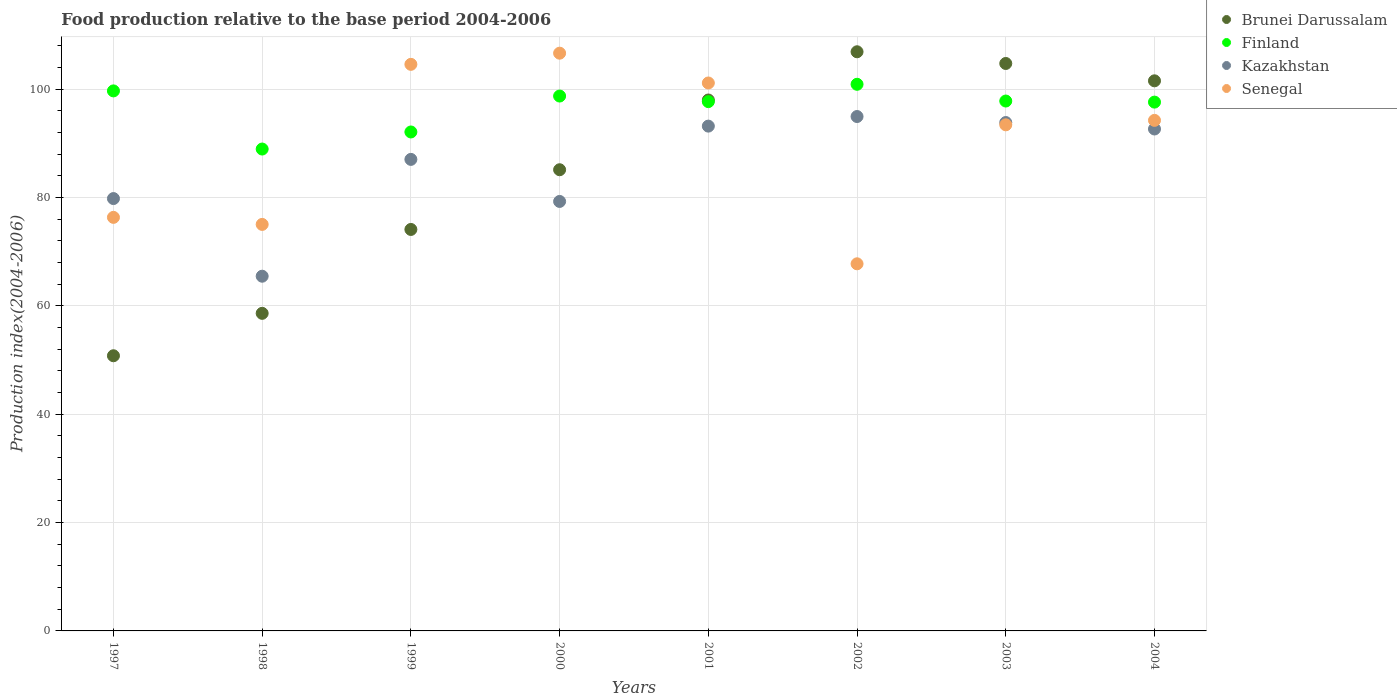How many different coloured dotlines are there?
Provide a succinct answer. 4. What is the food production index in Finland in 2002?
Ensure brevity in your answer.  100.88. Across all years, what is the maximum food production index in Finland?
Keep it short and to the point. 100.88. Across all years, what is the minimum food production index in Brunei Darussalam?
Offer a terse response. 50.78. What is the total food production index in Brunei Darussalam in the graph?
Make the answer very short. 679.69. What is the difference between the food production index in Senegal in 1998 and that in 2004?
Your answer should be very brief. -19.2. What is the difference between the food production index in Kazakhstan in 1997 and the food production index in Senegal in 2001?
Keep it short and to the point. -21.33. What is the average food production index in Finland per year?
Provide a succinct answer. 96.66. In the year 1998, what is the difference between the food production index in Senegal and food production index in Brunei Darussalam?
Ensure brevity in your answer.  16.41. What is the ratio of the food production index in Senegal in 1997 to that in 2003?
Offer a terse response. 0.82. What is the difference between the highest and the second highest food production index in Finland?
Your answer should be very brief. 1.22. What is the difference between the highest and the lowest food production index in Senegal?
Offer a very short reply. 38.87. Is the sum of the food production index in Finland in 1997 and 2002 greater than the maximum food production index in Brunei Darussalam across all years?
Ensure brevity in your answer.  Yes. Is it the case that in every year, the sum of the food production index in Finland and food production index in Senegal  is greater than the food production index in Kazakhstan?
Ensure brevity in your answer.  Yes. Does the food production index in Finland monotonically increase over the years?
Your response must be concise. No. Is the food production index in Kazakhstan strictly less than the food production index in Brunei Darussalam over the years?
Ensure brevity in your answer.  No. How many years are there in the graph?
Provide a short and direct response. 8. What is the difference between two consecutive major ticks on the Y-axis?
Ensure brevity in your answer.  20. Does the graph contain any zero values?
Your answer should be very brief. No. Where does the legend appear in the graph?
Your answer should be compact. Top right. How are the legend labels stacked?
Your answer should be compact. Vertical. What is the title of the graph?
Make the answer very short. Food production relative to the base period 2004-2006. Does "Albania" appear as one of the legend labels in the graph?
Give a very brief answer. No. What is the label or title of the X-axis?
Provide a short and direct response. Years. What is the label or title of the Y-axis?
Give a very brief answer. Production index(2004-2006). What is the Production index(2004-2006) of Brunei Darussalam in 1997?
Provide a short and direct response. 50.78. What is the Production index(2004-2006) in Finland in 1997?
Your answer should be very brief. 99.66. What is the Production index(2004-2006) of Kazakhstan in 1997?
Provide a succinct answer. 79.79. What is the Production index(2004-2006) in Senegal in 1997?
Your response must be concise. 76.32. What is the Production index(2004-2006) of Brunei Darussalam in 1998?
Your response must be concise. 58.61. What is the Production index(2004-2006) of Finland in 1998?
Ensure brevity in your answer.  88.93. What is the Production index(2004-2006) in Kazakhstan in 1998?
Provide a succinct answer. 65.46. What is the Production index(2004-2006) of Senegal in 1998?
Give a very brief answer. 75.02. What is the Production index(2004-2006) in Brunei Darussalam in 1999?
Make the answer very short. 74.09. What is the Production index(2004-2006) of Finland in 1999?
Make the answer very short. 92.08. What is the Production index(2004-2006) in Kazakhstan in 1999?
Offer a very short reply. 87.02. What is the Production index(2004-2006) in Senegal in 1999?
Offer a terse response. 104.56. What is the Production index(2004-2006) in Brunei Darussalam in 2000?
Provide a short and direct response. 85.11. What is the Production index(2004-2006) of Finland in 2000?
Make the answer very short. 98.71. What is the Production index(2004-2006) of Kazakhstan in 2000?
Give a very brief answer. 79.26. What is the Production index(2004-2006) in Senegal in 2000?
Offer a terse response. 106.62. What is the Production index(2004-2006) of Brunei Darussalam in 2001?
Your response must be concise. 97.98. What is the Production index(2004-2006) in Finland in 2001?
Keep it short and to the point. 97.68. What is the Production index(2004-2006) of Kazakhstan in 2001?
Your answer should be very brief. 93.16. What is the Production index(2004-2006) of Senegal in 2001?
Give a very brief answer. 101.12. What is the Production index(2004-2006) in Brunei Darussalam in 2002?
Your answer should be compact. 106.88. What is the Production index(2004-2006) in Finland in 2002?
Make the answer very short. 100.88. What is the Production index(2004-2006) in Kazakhstan in 2002?
Offer a very short reply. 94.93. What is the Production index(2004-2006) of Senegal in 2002?
Give a very brief answer. 67.75. What is the Production index(2004-2006) in Brunei Darussalam in 2003?
Your answer should be very brief. 104.72. What is the Production index(2004-2006) of Finland in 2003?
Offer a terse response. 97.79. What is the Production index(2004-2006) in Kazakhstan in 2003?
Ensure brevity in your answer.  93.82. What is the Production index(2004-2006) in Senegal in 2003?
Ensure brevity in your answer.  93.4. What is the Production index(2004-2006) in Brunei Darussalam in 2004?
Provide a short and direct response. 101.52. What is the Production index(2004-2006) in Finland in 2004?
Ensure brevity in your answer.  97.59. What is the Production index(2004-2006) in Kazakhstan in 2004?
Your answer should be very brief. 92.63. What is the Production index(2004-2006) of Senegal in 2004?
Keep it short and to the point. 94.22. Across all years, what is the maximum Production index(2004-2006) in Brunei Darussalam?
Give a very brief answer. 106.88. Across all years, what is the maximum Production index(2004-2006) in Finland?
Provide a succinct answer. 100.88. Across all years, what is the maximum Production index(2004-2006) of Kazakhstan?
Ensure brevity in your answer.  94.93. Across all years, what is the maximum Production index(2004-2006) of Senegal?
Keep it short and to the point. 106.62. Across all years, what is the minimum Production index(2004-2006) of Brunei Darussalam?
Offer a very short reply. 50.78. Across all years, what is the minimum Production index(2004-2006) of Finland?
Offer a very short reply. 88.93. Across all years, what is the minimum Production index(2004-2006) in Kazakhstan?
Make the answer very short. 65.46. Across all years, what is the minimum Production index(2004-2006) in Senegal?
Provide a succinct answer. 67.75. What is the total Production index(2004-2006) in Brunei Darussalam in the graph?
Your answer should be compact. 679.69. What is the total Production index(2004-2006) of Finland in the graph?
Your answer should be compact. 773.32. What is the total Production index(2004-2006) of Kazakhstan in the graph?
Provide a short and direct response. 686.07. What is the total Production index(2004-2006) of Senegal in the graph?
Offer a very short reply. 719.01. What is the difference between the Production index(2004-2006) in Brunei Darussalam in 1997 and that in 1998?
Give a very brief answer. -7.83. What is the difference between the Production index(2004-2006) in Finland in 1997 and that in 1998?
Offer a very short reply. 10.73. What is the difference between the Production index(2004-2006) of Kazakhstan in 1997 and that in 1998?
Your answer should be very brief. 14.33. What is the difference between the Production index(2004-2006) in Brunei Darussalam in 1997 and that in 1999?
Offer a terse response. -23.31. What is the difference between the Production index(2004-2006) of Finland in 1997 and that in 1999?
Offer a very short reply. 7.58. What is the difference between the Production index(2004-2006) of Kazakhstan in 1997 and that in 1999?
Provide a succinct answer. -7.23. What is the difference between the Production index(2004-2006) in Senegal in 1997 and that in 1999?
Make the answer very short. -28.24. What is the difference between the Production index(2004-2006) of Brunei Darussalam in 1997 and that in 2000?
Provide a succinct answer. -34.33. What is the difference between the Production index(2004-2006) of Kazakhstan in 1997 and that in 2000?
Your response must be concise. 0.53. What is the difference between the Production index(2004-2006) in Senegal in 1997 and that in 2000?
Keep it short and to the point. -30.3. What is the difference between the Production index(2004-2006) in Brunei Darussalam in 1997 and that in 2001?
Offer a terse response. -47.2. What is the difference between the Production index(2004-2006) of Finland in 1997 and that in 2001?
Keep it short and to the point. 1.98. What is the difference between the Production index(2004-2006) of Kazakhstan in 1997 and that in 2001?
Your response must be concise. -13.37. What is the difference between the Production index(2004-2006) of Senegal in 1997 and that in 2001?
Make the answer very short. -24.8. What is the difference between the Production index(2004-2006) in Brunei Darussalam in 1997 and that in 2002?
Give a very brief answer. -56.1. What is the difference between the Production index(2004-2006) of Finland in 1997 and that in 2002?
Provide a short and direct response. -1.22. What is the difference between the Production index(2004-2006) in Kazakhstan in 1997 and that in 2002?
Provide a short and direct response. -15.14. What is the difference between the Production index(2004-2006) of Senegal in 1997 and that in 2002?
Offer a terse response. 8.57. What is the difference between the Production index(2004-2006) in Brunei Darussalam in 1997 and that in 2003?
Ensure brevity in your answer.  -53.94. What is the difference between the Production index(2004-2006) in Finland in 1997 and that in 2003?
Your response must be concise. 1.87. What is the difference between the Production index(2004-2006) of Kazakhstan in 1997 and that in 2003?
Keep it short and to the point. -14.03. What is the difference between the Production index(2004-2006) in Senegal in 1997 and that in 2003?
Offer a terse response. -17.08. What is the difference between the Production index(2004-2006) in Brunei Darussalam in 1997 and that in 2004?
Offer a very short reply. -50.74. What is the difference between the Production index(2004-2006) of Finland in 1997 and that in 2004?
Offer a very short reply. 2.07. What is the difference between the Production index(2004-2006) of Kazakhstan in 1997 and that in 2004?
Keep it short and to the point. -12.84. What is the difference between the Production index(2004-2006) in Senegal in 1997 and that in 2004?
Your answer should be very brief. -17.9. What is the difference between the Production index(2004-2006) in Brunei Darussalam in 1998 and that in 1999?
Keep it short and to the point. -15.48. What is the difference between the Production index(2004-2006) of Finland in 1998 and that in 1999?
Your answer should be very brief. -3.15. What is the difference between the Production index(2004-2006) in Kazakhstan in 1998 and that in 1999?
Provide a short and direct response. -21.56. What is the difference between the Production index(2004-2006) of Senegal in 1998 and that in 1999?
Keep it short and to the point. -29.54. What is the difference between the Production index(2004-2006) of Brunei Darussalam in 1998 and that in 2000?
Your response must be concise. -26.5. What is the difference between the Production index(2004-2006) of Finland in 1998 and that in 2000?
Provide a succinct answer. -9.78. What is the difference between the Production index(2004-2006) in Kazakhstan in 1998 and that in 2000?
Offer a terse response. -13.8. What is the difference between the Production index(2004-2006) in Senegal in 1998 and that in 2000?
Provide a succinct answer. -31.6. What is the difference between the Production index(2004-2006) of Brunei Darussalam in 1998 and that in 2001?
Offer a very short reply. -39.37. What is the difference between the Production index(2004-2006) in Finland in 1998 and that in 2001?
Your answer should be compact. -8.75. What is the difference between the Production index(2004-2006) of Kazakhstan in 1998 and that in 2001?
Give a very brief answer. -27.7. What is the difference between the Production index(2004-2006) of Senegal in 1998 and that in 2001?
Your response must be concise. -26.1. What is the difference between the Production index(2004-2006) of Brunei Darussalam in 1998 and that in 2002?
Provide a short and direct response. -48.27. What is the difference between the Production index(2004-2006) in Finland in 1998 and that in 2002?
Make the answer very short. -11.95. What is the difference between the Production index(2004-2006) of Kazakhstan in 1998 and that in 2002?
Offer a terse response. -29.47. What is the difference between the Production index(2004-2006) in Senegal in 1998 and that in 2002?
Your answer should be compact. 7.27. What is the difference between the Production index(2004-2006) of Brunei Darussalam in 1998 and that in 2003?
Ensure brevity in your answer.  -46.11. What is the difference between the Production index(2004-2006) of Finland in 1998 and that in 2003?
Give a very brief answer. -8.86. What is the difference between the Production index(2004-2006) in Kazakhstan in 1998 and that in 2003?
Offer a very short reply. -28.36. What is the difference between the Production index(2004-2006) of Senegal in 1998 and that in 2003?
Offer a very short reply. -18.38. What is the difference between the Production index(2004-2006) of Brunei Darussalam in 1998 and that in 2004?
Your answer should be compact. -42.91. What is the difference between the Production index(2004-2006) of Finland in 1998 and that in 2004?
Provide a succinct answer. -8.66. What is the difference between the Production index(2004-2006) of Kazakhstan in 1998 and that in 2004?
Your answer should be compact. -27.17. What is the difference between the Production index(2004-2006) in Senegal in 1998 and that in 2004?
Your response must be concise. -19.2. What is the difference between the Production index(2004-2006) of Brunei Darussalam in 1999 and that in 2000?
Ensure brevity in your answer.  -11.02. What is the difference between the Production index(2004-2006) of Finland in 1999 and that in 2000?
Your answer should be very brief. -6.63. What is the difference between the Production index(2004-2006) of Kazakhstan in 1999 and that in 2000?
Your answer should be very brief. 7.76. What is the difference between the Production index(2004-2006) of Senegal in 1999 and that in 2000?
Provide a short and direct response. -2.06. What is the difference between the Production index(2004-2006) of Brunei Darussalam in 1999 and that in 2001?
Your answer should be very brief. -23.89. What is the difference between the Production index(2004-2006) in Kazakhstan in 1999 and that in 2001?
Give a very brief answer. -6.14. What is the difference between the Production index(2004-2006) of Senegal in 1999 and that in 2001?
Offer a very short reply. 3.44. What is the difference between the Production index(2004-2006) in Brunei Darussalam in 1999 and that in 2002?
Your response must be concise. -32.79. What is the difference between the Production index(2004-2006) of Finland in 1999 and that in 2002?
Offer a very short reply. -8.8. What is the difference between the Production index(2004-2006) of Kazakhstan in 1999 and that in 2002?
Make the answer very short. -7.91. What is the difference between the Production index(2004-2006) of Senegal in 1999 and that in 2002?
Make the answer very short. 36.81. What is the difference between the Production index(2004-2006) of Brunei Darussalam in 1999 and that in 2003?
Give a very brief answer. -30.63. What is the difference between the Production index(2004-2006) in Finland in 1999 and that in 2003?
Provide a short and direct response. -5.71. What is the difference between the Production index(2004-2006) in Senegal in 1999 and that in 2003?
Your response must be concise. 11.16. What is the difference between the Production index(2004-2006) of Brunei Darussalam in 1999 and that in 2004?
Make the answer very short. -27.43. What is the difference between the Production index(2004-2006) of Finland in 1999 and that in 2004?
Your response must be concise. -5.51. What is the difference between the Production index(2004-2006) in Kazakhstan in 1999 and that in 2004?
Your response must be concise. -5.61. What is the difference between the Production index(2004-2006) in Senegal in 1999 and that in 2004?
Your response must be concise. 10.34. What is the difference between the Production index(2004-2006) of Brunei Darussalam in 2000 and that in 2001?
Your answer should be very brief. -12.87. What is the difference between the Production index(2004-2006) in Senegal in 2000 and that in 2001?
Make the answer very short. 5.5. What is the difference between the Production index(2004-2006) in Brunei Darussalam in 2000 and that in 2002?
Your answer should be compact. -21.77. What is the difference between the Production index(2004-2006) in Finland in 2000 and that in 2002?
Ensure brevity in your answer.  -2.17. What is the difference between the Production index(2004-2006) in Kazakhstan in 2000 and that in 2002?
Keep it short and to the point. -15.67. What is the difference between the Production index(2004-2006) in Senegal in 2000 and that in 2002?
Keep it short and to the point. 38.87. What is the difference between the Production index(2004-2006) in Brunei Darussalam in 2000 and that in 2003?
Ensure brevity in your answer.  -19.61. What is the difference between the Production index(2004-2006) of Kazakhstan in 2000 and that in 2003?
Your answer should be compact. -14.56. What is the difference between the Production index(2004-2006) of Senegal in 2000 and that in 2003?
Your response must be concise. 13.22. What is the difference between the Production index(2004-2006) of Brunei Darussalam in 2000 and that in 2004?
Offer a very short reply. -16.41. What is the difference between the Production index(2004-2006) in Finland in 2000 and that in 2004?
Your answer should be very brief. 1.12. What is the difference between the Production index(2004-2006) in Kazakhstan in 2000 and that in 2004?
Provide a succinct answer. -13.37. What is the difference between the Production index(2004-2006) in Senegal in 2000 and that in 2004?
Make the answer very short. 12.4. What is the difference between the Production index(2004-2006) of Kazakhstan in 2001 and that in 2002?
Offer a terse response. -1.77. What is the difference between the Production index(2004-2006) of Senegal in 2001 and that in 2002?
Your response must be concise. 33.37. What is the difference between the Production index(2004-2006) in Brunei Darussalam in 2001 and that in 2003?
Your answer should be very brief. -6.74. What is the difference between the Production index(2004-2006) of Finland in 2001 and that in 2003?
Give a very brief answer. -0.11. What is the difference between the Production index(2004-2006) in Kazakhstan in 2001 and that in 2003?
Make the answer very short. -0.66. What is the difference between the Production index(2004-2006) of Senegal in 2001 and that in 2003?
Your answer should be very brief. 7.72. What is the difference between the Production index(2004-2006) of Brunei Darussalam in 2001 and that in 2004?
Ensure brevity in your answer.  -3.54. What is the difference between the Production index(2004-2006) of Finland in 2001 and that in 2004?
Your answer should be very brief. 0.09. What is the difference between the Production index(2004-2006) in Kazakhstan in 2001 and that in 2004?
Keep it short and to the point. 0.53. What is the difference between the Production index(2004-2006) in Senegal in 2001 and that in 2004?
Your response must be concise. 6.9. What is the difference between the Production index(2004-2006) in Brunei Darussalam in 2002 and that in 2003?
Keep it short and to the point. 2.16. What is the difference between the Production index(2004-2006) of Finland in 2002 and that in 2003?
Offer a very short reply. 3.09. What is the difference between the Production index(2004-2006) of Kazakhstan in 2002 and that in 2003?
Keep it short and to the point. 1.11. What is the difference between the Production index(2004-2006) in Senegal in 2002 and that in 2003?
Your answer should be very brief. -25.65. What is the difference between the Production index(2004-2006) in Brunei Darussalam in 2002 and that in 2004?
Give a very brief answer. 5.36. What is the difference between the Production index(2004-2006) of Finland in 2002 and that in 2004?
Keep it short and to the point. 3.29. What is the difference between the Production index(2004-2006) in Kazakhstan in 2002 and that in 2004?
Your answer should be very brief. 2.3. What is the difference between the Production index(2004-2006) in Senegal in 2002 and that in 2004?
Offer a very short reply. -26.47. What is the difference between the Production index(2004-2006) in Brunei Darussalam in 2003 and that in 2004?
Your response must be concise. 3.2. What is the difference between the Production index(2004-2006) in Kazakhstan in 2003 and that in 2004?
Your answer should be very brief. 1.19. What is the difference between the Production index(2004-2006) of Senegal in 2003 and that in 2004?
Make the answer very short. -0.82. What is the difference between the Production index(2004-2006) in Brunei Darussalam in 1997 and the Production index(2004-2006) in Finland in 1998?
Ensure brevity in your answer.  -38.15. What is the difference between the Production index(2004-2006) in Brunei Darussalam in 1997 and the Production index(2004-2006) in Kazakhstan in 1998?
Make the answer very short. -14.68. What is the difference between the Production index(2004-2006) in Brunei Darussalam in 1997 and the Production index(2004-2006) in Senegal in 1998?
Give a very brief answer. -24.24. What is the difference between the Production index(2004-2006) of Finland in 1997 and the Production index(2004-2006) of Kazakhstan in 1998?
Ensure brevity in your answer.  34.2. What is the difference between the Production index(2004-2006) in Finland in 1997 and the Production index(2004-2006) in Senegal in 1998?
Keep it short and to the point. 24.64. What is the difference between the Production index(2004-2006) of Kazakhstan in 1997 and the Production index(2004-2006) of Senegal in 1998?
Give a very brief answer. 4.77. What is the difference between the Production index(2004-2006) in Brunei Darussalam in 1997 and the Production index(2004-2006) in Finland in 1999?
Your response must be concise. -41.3. What is the difference between the Production index(2004-2006) in Brunei Darussalam in 1997 and the Production index(2004-2006) in Kazakhstan in 1999?
Offer a terse response. -36.24. What is the difference between the Production index(2004-2006) of Brunei Darussalam in 1997 and the Production index(2004-2006) of Senegal in 1999?
Keep it short and to the point. -53.78. What is the difference between the Production index(2004-2006) of Finland in 1997 and the Production index(2004-2006) of Kazakhstan in 1999?
Offer a very short reply. 12.64. What is the difference between the Production index(2004-2006) in Finland in 1997 and the Production index(2004-2006) in Senegal in 1999?
Offer a very short reply. -4.9. What is the difference between the Production index(2004-2006) of Kazakhstan in 1997 and the Production index(2004-2006) of Senegal in 1999?
Ensure brevity in your answer.  -24.77. What is the difference between the Production index(2004-2006) of Brunei Darussalam in 1997 and the Production index(2004-2006) of Finland in 2000?
Provide a short and direct response. -47.93. What is the difference between the Production index(2004-2006) in Brunei Darussalam in 1997 and the Production index(2004-2006) in Kazakhstan in 2000?
Provide a short and direct response. -28.48. What is the difference between the Production index(2004-2006) in Brunei Darussalam in 1997 and the Production index(2004-2006) in Senegal in 2000?
Provide a short and direct response. -55.84. What is the difference between the Production index(2004-2006) in Finland in 1997 and the Production index(2004-2006) in Kazakhstan in 2000?
Your answer should be compact. 20.4. What is the difference between the Production index(2004-2006) of Finland in 1997 and the Production index(2004-2006) of Senegal in 2000?
Offer a terse response. -6.96. What is the difference between the Production index(2004-2006) of Kazakhstan in 1997 and the Production index(2004-2006) of Senegal in 2000?
Your answer should be very brief. -26.83. What is the difference between the Production index(2004-2006) of Brunei Darussalam in 1997 and the Production index(2004-2006) of Finland in 2001?
Keep it short and to the point. -46.9. What is the difference between the Production index(2004-2006) in Brunei Darussalam in 1997 and the Production index(2004-2006) in Kazakhstan in 2001?
Offer a terse response. -42.38. What is the difference between the Production index(2004-2006) in Brunei Darussalam in 1997 and the Production index(2004-2006) in Senegal in 2001?
Provide a succinct answer. -50.34. What is the difference between the Production index(2004-2006) of Finland in 1997 and the Production index(2004-2006) of Kazakhstan in 2001?
Give a very brief answer. 6.5. What is the difference between the Production index(2004-2006) in Finland in 1997 and the Production index(2004-2006) in Senegal in 2001?
Offer a very short reply. -1.46. What is the difference between the Production index(2004-2006) of Kazakhstan in 1997 and the Production index(2004-2006) of Senegal in 2001?
Your answer should be very brief. -21.33. What is the difference between the Production index(2004-2006) of Brunei Darussalam in 1997 and the Production index(2004-2006) of Finland in 2002?
Keep it short and to the point. -50.1. What is the difference between the Production index(2004-2006) in Brunei Darussalam in 1997 and the Production index(2004-2006) in Kazakhstan in 2002?
Ensure brevity in your answer.  -44.15. What is the difference between the Production index(2004-2006) of Brunei Darussalam in 1997 and the Production index(2004-2006) of Senegal in 2002?
Provide a short and direct response. -16.97. What is the difference between the Production index(2004-2006) in Finland in 1997 and the Production index(2004-2006) in Kazakhstan in 2002?
Offer a terse response. 4.73. What is the difference between the Production index(2004-2006) of Finland in 1997 and the Production index(2004-2006) of Senegal in 2002?
Keep it short and to the point. 31.91. What is the difference between the Production index(2004-2006) of Kazakhstan in 1997 and the Production index(2004-2006) of Senegal in 2002?
Your answer should be very brief. 12.04. What is the difference between the Production index(2004-2006) of Brunei Darussalam in 1997 and the Production index(2004-2006) of Finland in 2003?
Provide a short and direct response. -47.01. What is the difference between the Production index(2004-2006) in Brunei Darussalam in 1997 and the Production index(2004-2006) in Kazakhstan in 2003?
Offer a very short reply. -43.04. What is the difference between the Production index(2004-2006) of Brunei Darussalam in 1997 and the Production index(2004-2006) of Senegal in 2003?
Offer a terse response. -42.62. What is the difference between the Production index(2004-2006) of Finland in 1997 and the Production index(2004-2006) of Kazakhstan in 2003?
Keep it short and to the point. 5.84. What is the difference between the Production index(2004-2006) of Finland in 1997 and the Production index(2004-2006) of Senegal in 2003?
Your answer should be compact. 6.26. What is the difference between the Production index(2004-2006) of Kazakhstan in 1997 and the Production index(2004-2006) of Senegal in 2003?
Give a very brief answer. -13.61. What is the difference between the Production index(2004-2006) in Brunei Darussalam in 1997 and the Production index(2004-2006) in Finland in 2004?
Provide a short and direct response. -46.81. What is the difference between the Production index(2004-2006) in Brunei Darussalam in 1997 and the Production index(2004-2006) in Kazakhstan in 2004?
Provide a succinct answer. -41.85. What is the difference between the Production index(2004-2006) of Brunei Darussalam in 1997 and the Production index(2004-2006) of Senegal in 2004?
Your answer should be very brief. -43.44. What is the difference between the Production index(2004-2006) in Finland in 1997 and the Production index(2004-2006) in Kazakhstan in 2004?
Keep it short and to the point. 7.03. What is the difference between the Production index(2004-2006) in Finland in 1997 and the Production index(2004-2006) in Senegal in 2004?
Offer a terse response. 5.44. What is the difference between the Production index(2004-2006) of Kazakhstan in 1997 and the Production index(2004-2006) of Senegal in 2004?
Provide a short and direct response. -14.43. What is the difference between the Production index(2004-2006) of Brunei Darussalam in 1998 and the Production index(2004-2006) of Finland in 1999?
Offer a very short reply. -33.47. What is the difference between the Production index(2004-2006) in Brunei Darussalam in 1998 and the Production index(2004-2006) in Kazakhstan in 1999?
Make the answer very short. -28.41. What is the difference between the Production index(2004-2006) in Brunei Darussalam in 1998 and the Production index(2004-2006) in Senegal in 1999?
Your answer should be very brief. -45.95. What is the difference between the Production index(2004-2006) in Finland in 1998 and the Production index(2004-2006) in Kazakhstan in 1999?
Your answer should be compact. 1.91. What is the difference between the Production index(2004-2006) of Finland in 1998 and the Production index(2004-2006) of Senegal in 1999?
Offer a terse response. -15.63. What is the difference between the Production index(2004-2006) in Kazakhstan in 1998 and the Production index(2004-2006) in Senegal in 1999?
Your answer should be very brief. -39.1. What is the difference between the Production index(2004-2006) of Brunei Darussalam in 1998 and the Production index(2004-2006) of Finland in 2000?
Ensure brevity in your answer.  -40.1. What is the difference between the Production index(2004-2006) in Brunei Darussalam in 1998 and the Production index(2004-2006) in Kazakhstan in 2000?
Keep it short and to the point. -20.65. What is the difference between the Production index(2004-2006) of Brunei Darussalam in 1998 and the Production index(2004-2006) of Senegal in 2000?
Offer a terse response. -48.01. What is the difference between the Production index(2004-2006) in Finland in 1998 and the Production index(2004-2006) in Kazakhstan in 2000?
Your response must be concise. 9.67. What is the difference between the Production index(2004-2006) in Finland in 1998 and the Production index(2004-2006) in Senegal in 2000?
Your response must be concise. -17.69. What is the difference between the Production index(2004-2006) of Kazakhstan in 1998 and the Production index(2004-2006) of Senegal in 2000?
Your answer should be very brief. -41.16. What is the difference between the Production index(2004-2006) of Brunei Darussalam in 1998 and the Production index(2004-2006) of Finland in 2001?
Your answer should be compact. -39.07. What is the difference between the Production index(2004-2006) in Brunei Darussalam in 1998 and the Production index(2004-2006) in Kazakhstan in 2001?
Your answer should be compact. -34.55. What is the difference between the Production index(2004-2006) in Brunei Darussalam in 1998 and the Production index(2004-2006) in Senegal in 2001?
Offer a terse response. -42.51. What is the difference between the Production index(2004-2006) in Finland in 1998 and the Production index(2004-2006) in Kazakhstan in 2001?
Provide a short and direct response. -4.23. What is the difference between the Production index(2004-2006) of Finland in 1998 and the Production index(2004-2006) of Senegal in 2001?
Offer a very short reply. -12.19. What is the difference between the Production index(2004-2006) of Kazakhstan in 1998 and the Production index(2004-2006) of Senegal in 2001?
Provide a succinct answer. -35.66. What is the difference between the Production index(2004-2006) of Brunei Darussalam in 1998 and the Production index(2004-2006) of Finland in 2002?
Make the answer very short. -42.27. What is the difference between the Production index(2004-2006) in Brunei Darussalam in 1998 and the Production index(2004-2006) in Kazakhstan in 2002?
Provide a short and direct response. -36.32. What is the difference between the Production index(2004-2006) in Brunei Darussalam in 1998 and the Production index(2004-2006) in Senegal in 2002?
Provide a short and direct response. -9.14. What is the difference between the Production index(2004-2006) of Finland in 1998 and the Production index(2004-2006) of Kazakhstan in 2002?
Offer a very short reply. -6. What is the difference between the Production index(2004-2006) in Finland in 1998 and the Production index(2004-2006) in Senegal in 2002?
Provide a short and direct response. 21.18. What is the difference between the Production index(2004-2006) in Kazakhstan in 1998 and the Production index(2004-2006) in Senegal in 2002?
Offer a very short reply. -2.29. What is the difference between the Production index(2004-2006) of Brunei Darussalam in 1998 and the Production index(2004-2006) of Finland in 2003?
Make the answer very short. -39.18. What is the difference between the Production index(2004-2006) in Brunei Darussalam in 1998 and the Production index(2004-2006) in Kazakhstan in 2003?
Offer a very short reply. -35.21. What is the difference between the Production index(2004-2006) in Brunei Darussalam in 1998 and the Production index(2004-2006) in Senegal in 2003?
Provide a short and direct response. -34.79. What is the difference between the Production index(2004-2006) in Finland in 1998 and the Production index(2004-2006) in Kazakhstan in 2003?
Offer a terse response. -4.89. What is the difference between the Production index(2004-2006) in Finland in 1998 and the Production index(2004-2006) in Senegal in 2003?
Make the answer very short. -4.47. What is the difference between the Production index(2004-2006) in Kazakhstan in 1998 and the Production index(2004-2006) in Senegal in 2003?
Your response must be concise. -27.94. What is the difference between the Production index(2004-2006) of Brunei Darussalam in 1998 and the Production index(2004-2006) of Finland in 2004?
Keep it short and to the point. -38.98. What is the difference between the Production index(2004-2006) of Brunei Darussalam in 1998 and the Production index(2004-2006) of Kazakhstan in 2004?
Keep it short and to the point. -34.02. What is the difference between the Production index(2004-2006) of Brunei Darussalam in 1998 and the Production index(2004-2006) of Senegal in 2004?
Your response must be concise. -35.61. What is the difference between the Production index(2004-2006) of Finland in 1998 and the Production index(2004-2006) of Senegal in 2004?
Offer a terse response. -5.29. What is the difference between the Production index(2004-2006) in Kazakhstan in 1998 and the Production index(2004-2006) in Senegal in 2004?
Provide a succinct answer. -28.76. What is the difference between the Production index(2004-2006) of Brunei Darussalam in 1999 and the Production index(2004-2006) of Finland in 2000?
Provide a succinct answer. -24.62. What is the difference between the Production index(2004-2006) of Brunei Darussalam in 1999 and the Production index(2004-2006) of Kazakhstan in 2000?
Give a very brief answer. -5.17. What is the difference between the Production index(2004-2006) in Brunei Darussalam in 1999 and the Production index(2004-2006) in Senegal in 2000?
Your response must be concise. -32.53. What is the difference between the Production index(2004-2006) of Finland in 1999 and the Production index(2004-2006) of Kazakhstan in 2000?
Your answer should be compact. 12.82. What is the difference between the Production index(2004-2006) in Finland in 1999 and the Production index(2004-2006) in Senegal in 2000?
Keep it short and to the point. -14.54. What is the difference between the Production index(2004-2006) in Kazakhstan in 1999 and the Production index(2004-2006) in Senegal in 2000?
Ensure brevity in your answer.  -19.6. What is the difference between the Production index(2004-2006) of Brunei Darussalam in 1999 and the Production index(2004-2006) of Finland in 2001?
Keep it short and to the point. -23.59. What is the difference between the Production index(2004-2006) in Brunei Darussalam in 1999 and the Production index(2004-2006) in Kazakhstan in 2001?
Your response must be concise. -19.07. What is the difference between the Production index(2004-2006) in Brunei Darussalam in 1999 and the Production index(2004-2006) in Senegal in 2001?
Offer a very short reply. -27.03. What is the difference between the Production index(2004-2006) in Finland in 1999 and the Production index(2004-2006) in Kazakhstan in 2001?
Ensure brevity in your answer.  -1.08. What is the difference between the Production index(2004-2006) in Finland in 1999 and the Production index(2004-2006) in Senegal in 2001?
Give a very brief answer. -9.04. What is the difference between the Production index(2004-2006) of Kazakhstan in 1999 and the Production index(2004-2006) of Senegal in 2001?
Provide a short and direct response. -14.1. What is the difference between the Production index(2004-2006) in Brunei Darussalam in 1999 and the Production index(2004-2006) in Finland in 2002?
Provide a succinct answer. -26.79. What is the difference between the Production index(2004-2006) in Brunei Darussalam in 1999 and the Production index(2004-2006) in Kazakhstan in 2002?
Provide a short and direct response. -20.84. What is the difference between the Production index(2004-2006) of Brunei Darussalam in 1999 and the Production index(2004-2006) of Senegal in 2002?
Ensure brevity in your answer.  6.34. What is the difference between the Production index(2004-2006) of Finland in 1999 and the Production index(2004-2006) of Kazakhstan in 2002?
Make the answer very short. -2.85. What is the difference between the Production index(2004-2006) of Finland in 1999 and the Production index(2004-2006) of Senegal in 2002?
Your response must be concise. 24.33. What is the difference between the Production index(2004-2006) of Kazakhstan in 1999 and the Production index(2004-2006) of Senegal in 2002?
Provide a succinct answer. 19.27. What is the difference between the Production index(2004-2006) of Brunei Darussalam in 1999 and the Production index(2004-2006) of Finland in 2003?
Provide a succinct answer. -23.7. What is the difference between the Production index(2004-2006) of Brunei Darussalam in 1999 and the Production index(2004-2006) of Kazakhstan in 2003?
Provide a succinct answer. -19.73. What is the difference between the Production index(2004-2006) in Brunei Darussalam in 1999 and the Production index(2004-2006) in Senegal in 2003?
Provide a short and direct response. -19.31. What is the difference between the Production index(2004-2006) in Finland in 1999 and the Production index(2004-2006) in Kazakhstan in 2003?
Ensure brevity in your answer.  -1.74. What is the difference between the Production index(2004-2006) in Finland in 1999 and the Production index(2004-2006) in Senegal in 2003?
Offer a very short reply. -1.32. What is the difference between the Production index(2004-2006) in Kazakhstan in 1999 and the Production index(2004-2006) in Senegal in 2003?
Keep it short and to the point. -6.38. What is the difference between the Production index(2004-2006) of Brunei Darussalam in 1999 and the Production index(2004-2006) of Finland in 2004?
Your response must be concise. -23.5. What is the difference between the Production index(2004-2006) of Brunei Darussalam in 1999 and the Production index(2004-2006) of Kazakhstan in 2004?
Your answer should be compact. -18.54. What is the difference between the Production index(2004-2006) in Brunei Darussalam in 1999 and the Production index(2004-2006) in Senegal in 2004?
Your answer should be compact. -20.13. What is the difference between the Production index(2004-2006) of Finland in 1999 and the Production index(2004-2006) of Kazakhstan in 2004?
Ensure brevity in your answer.  -0.55. What is the difference between the Production index(2004-2006) of Finland in 1999 and the Production index(2004-2006) of Senegal in 2004?
Your response must be concise. -2.14. What is the difference between the Production index(2004-2006) of Kazakhstan in 1999 and the Production index(2004-2006) of Senegal in 2004?
Offer a terse response. -7.2. What is the difference between the Production index(2004-2006) in Brunei Darussalam in 2000 and the Production index(2004-2006) in Finland in 2001?
Give a very brief answer. -12.57. What is the difference between the Production index(2004-2006) of Brunei Darussalam in 2000 and the Production index(2004-2006) of Kazakhstan in 2001?
Your answer should be very brief. -8.05. What is the difference between the Production index(2004-2006) in Brunei Darussalam in 2000 and the Production index(2004-2006) in Senegal in 2001?
Provide a short and direct response. -16.01. What is the difference between the Production index(2004-2006) of Finland in 2000 and the Production index(2004-2006) of Kazakhstan in 2001?
Offer a terse response. 5.55. What is the difference between the Production index(2004-2006) of Finland in 2000 and the Production index(2004-2006) of Senegal in 2001?
Your answer should be very brief. -2.41. What is the difference between the Production index(2004-2006) of Kazakhstan in 2000 and the Production index(2004-2006) of Senegal in 2001?
Your answer should be very brief. -21.86. What is the difference between the Production index(2004-2006) in Brunei Darussalam in 2000 and the Production index(2004-2006) in Finland in 2002?
Your answer should be compact. -15.77. What is the difference between the Production index(2004-2006) in Brunei Darussalam in 2000 and the Production index(2004-2006) in Kazakhstan in 2002?
Offer a terse response. -9.82. What is the difference between the Production index(2004-2006) in Brunei Darussalam in 2000 and the Production index(2004-2006) in Senegal in 2002?
Your answer should be compact. 17.36. What is the difference between the Production index(2004-2006) of Finland in 2000 and the Production index(2004-2006) of Kazakhstan in 2002?
Keep it short and to the point. 3.78. What is the difference between the Production index(2004-2006) of Finland in 2000 and the Production index(2004-2006) of Senegal in 2002?
Your answer should be compact. 30.96. What is the difference between the Production index(2004-2006) in Kazakhstan in 2000 and the Production index(2004-2006) in Senegal in 2002?
Offer a terse response. 11.51. What is the difference between the Production index(2004-2006) of Brunei Darussalam in 2000 and the Production index(2004-2006) of Finland in 2003?
Your answer should be compact. -12.68. What is the difference between the Production index(2004-2006) of Brunei Darussalam in 2000 and the Production index(2004-2006) of Kazakhstan in 2003?
Your answer should be compact. -8.71. What is the difference between the Production index(2004-2006) of Brunei Darussalam in 2000 and the Production index(2004-2006) of Senegal in 2003?
Offer a terse response. -8.29. What is the difference between the Production index(2004-2006) of Finland in 2000 and the Production index(2004-2006) of Kazakhstan in 2003?
Ensure brevity in your answer.  4.89. What is the difference between the Production index(2004-2006) of Finland in 2000 and the Production index(2004-2006) of Senegal in 2003?
Provide a succinct answer. 5.31. What is the difference between the Production index(2004-2006) in Kazakhstan in 2000 and the Production index(2004-2006) in Senegal in 2003?
Your answer should be very brief. -14.14. What is the difference between the Production index(2004-2006) in Brunei Darussalam in 2000 and the Production index(2004-2006) in Finland in 2004?
Ensure brevity in your answer.  -12.48. What is the difference between the Production index(2004-2006) of Brunei Darussalam in 2000 and the Production index(2004-2006) of Kazakhstan in 2004?
Your answer should be compact. -7.52. What is the difference between the Production index(2004-2006) in Brunei Darussalam in 2000 and the Production index(2004-2006) in Senegal in 2004?
Offer a very short reply. -9.11. What is the difference between the Production index(2004-2006) of Finland in 2000 and the Production index(2004-2006) of Kazakhstan in 2004?
Give a very brief answer. 6.08. What is the difference between the Production index(2004-2006) in Finland in 2000 and the Production index(2004-2006) in Senegal in 2004?
Ensure brevity in your answer.  4.49. What is the difference between the Production index(2004-2006) of Kazakhstan in 2000 and the Production index(2004-2006) of Senegal in 2004?
Give a very brief answer. -14.96. What is the difference between the Production index(2004-2006) in Brunei Darussalam in 2001 and the Production index(2004-2006) in Kazakhstan in 2002?
Keep it short and to the point. 3.05. What is the difference between the Production index(2004-2006) of Brunei Darussalam in 2001 and the Production index(2004-2006) of Senegal in 2002?
Your response must be concise. 30.23. What is the difference between the Production index(2004-2006) in Finland in 2001 and the Production index(2004-2006) in Kazakhstan in 2002?
Give a very brief answer. 2.75. What is the difference between the Production index(2004-2006) in Finland in 2001 and the Production index(2004-2006) in Senegal in 2002?
Ensure brevity in your answer.  29.93. What is the difference between the Production index(2004-2006) in Kazakhstan in 2001 and the Production index(2004-2006) in Senegal in 2002?
Your response must be concise. 25.41. What is the difference between the Production index(2004-2006) of Brunei Darussalam in 2001 and the Production index(2004-2006) of Finland in 2003?
Give a very brief answer. 0.19. What is the difference between the Production index(2004-2006) of Brunei Darussalam in 2001 and the Production index(2004-2006) of Kazakhstan in 2003?
Keep it short and to the point. 4.16. What is the difference between the Production index(2004-2006) of Brunei Darussalam in 2001 and the Production index(2004-2006) of Senegal in 2003?
Your answer should be very brief. 4.58. What is the difference between the Production index(2004-2006) in Finland in 2001 and the Production index(2004-2006) in Kazakhstan in 2003?
Provide a succinct answer. 3.86. What is the difference between the Production index(2004-2006) of Finland in 2001 and the Production index(2004-2006) of Senegal in 2003?
Give a very brief answer. 4.28. What is the difference between the Production index(2004-2006) in Kazakhstan in 2001 and the Production index(2004-2006) in Senegal in 2003?
Give a very brief answer. -0.24. What is the difference between the Production index(2004-2006) in Brunei Darussalam in 2001 and the Production index(2004-2006) in Finland in 2004?
Keep it short and to the point. 0.39. What is the difference between the Production index(2004-2006) of Brunei Darussalam in 2001 and the Production index(2004-2006) of Kazakhstan in 2004?
Offer a terse response. 5.35. What is the difference between the Production index(2004-2006) of Brunei Darussalam in 2001 and the Production index(2004-2006) of Senegal in 2004?
Give a very brief answer. 3.76. What is the difference between the Production index(2004-2006) of Finland in 2001 and the Production index(2004-2006) of Kazakhstan in 2004?
Provide a short and direct response. 5.05. What is the difference between the Production index(2004-2006) in Finland in 2001 and the Production index(2004-2006) in Senegal in 2004?
Provide a short and direct response. 3.46. What is the difference between the Production index(2004-2006) of Kazakhstan in 2001 and the Production index(2004-2006) of Senegal in 2004?
Provide a succinct answer. -1.06. What is the difference between the Production index(2004-2006) in Brunei Darussalam in 2002 and the Production index(2004-2006) in Finland in 2003?
Keep it short and to the point. 9.09. What is the difference between the Production index(2004-2006) in Brunei Darussalam in 2002 and the Production index(2004-2006) in Kazakhstan in 2003?
Keep it short and to the point. 13.06. What is the difference between the Production index(2004-2006) in Brunei Darussalam in 2002 and the Production index(2004-2006) in Senegal in 2003?
Your response must be concise. 13.48. What is the difference between the Production index(2004-2006) of Finland in 2002 and the Production index(2004-2006) of Kazakhstan in 2003?
Offer a very short reply. 7.06. What is the difference between the Production index(2004-2006) of Finland in 2002 and the Production index(2004-2006) of Senegal in 2003?
Your answer should be very brief. 7.48. What is the difference between the Production index(2004-2006) in Kazakhstan in 2002 and the Production index(2004-2006) in Senegal in 2003?
Give a very brief answer. 1.53. What is the difference between the Production index(2004-2006) in Brunei Darussalam in 2002 and the Production index(2004-2006) in Finland in 2004?
Ensure brevity in your answer.  9.29. What is the difference between the Production index(2004-2006) in Brunei Darussalam in 2002 and the Production index(2004-2006) in Kazakhstan in 2004?
Your response must be concise. 14.25. What is the difference between the Production index(2004-2006) in Brunei Darussalam in 2002 and the Production index(2004-2006) in Senegal in 2004?
Your response must be concise. 12.66. What is the difference between the Production index(2004-2006) in Finland in 2002 and the Production index(2004-2006) in Kazakhstan in 2004?
Make the answer very short. 8.25. What is the difference between the Production index(2004-2006) in Finland in 2002 and the Production index(2004-2006) in Senegal in 2004?
Offer a very short reply. 6.66. What is the difference between the Production index(2004-2006) in Kazakhstan in 2002 and the Production index(2004-2006) in Senegal in 2004?
Make the answer very short. 0.71. What is the difference between the Production index(2004-2006) of Brunei Darussalam in 2003 and the Production index(2004-2006) of Finland in 2004?
Your response must be concise. 7.13. What is the difference between the Production index(2004-2006) in Brunei Darussalam in 2003 and the Production index(2004-2006) in Kazakhstan in 2004?
Make the answer very short. 12.09. What is the difference between the Production index(2004-2006) of Finland in 2003 and the Production index(2004-2006) of Kazakhstan in 2004?
Ensure brevity in your answer.  5.16. What is the difference between the Production index(2004-2006) in Finland in 2003 and the Production index(2004-2006) in Senegal in 2004?
Provide a short and direct response. 3.57. What is the average Production index(2004-2006) in Brunei Darussalam per year?
Your answer should be very brief. 84.96. What is the average Production index(2004-2006) of Finland per year?
Your answer should be compact. 96.67. What is the average Production index(2004-2006) of Kazakhstan per year?
Keep it short and to the point. 85.76. What is the average Production index(2004-2006) in Senegal per year?
Your answer should be compact. 89.88. In the year 1997, what is the difference between the Production index(2004-2006) in Brunei Darussalam and Production index(2004-2006) in Finland?
Ensure brevity in your answer.  -48.88. In the year 1997, what is the difference between the Production index(2004-2006) of Brunei Darussalam and Production index(2004-2006) of Kazakhstan?
Keep it short and to the point. -29.01. In the year 1997, what is the difference between the Production index(2004-2006) in Brunei Darussalam and Production index(2004-2006) in Senegal?
Provide a succinct answer. -25.54. In the year 1997, what is the difference between the Production index(2004-2006) in Finland and Production index(2004-2006) in Kazakhstan?
Your answer should be compact. 19.87. In the year 1997, what is the difference between the Production index(2004-2006) of Finland and Production index(2004-2006) of Senegal?
Provide a succinct answer. 23.34. In the year 1997, what is the difference between the Production index(2004-2006) of Kazakhstan and Production index(2004-2006) of Senegal?
Ensure brevity in your answer.  3.47. In the year 1998, what is the difference between the Production index(2004-2006) of Brunei Darussalam and Production index(2004-2006) of Finland?
Your answer should be compact. -30.32. In the year 1998, what is the difference between the Production index(2004-2006) of Brunei Darussalam and Production index(2004-2006) of Kazakhstan?
Offer a very short reply. -6.85. In the year 1998, what is the difference between the Production index(2004-2006) of Brunei Darussalam and Production index(2004-2006) of Senegal?
Give a very brief answer. -16.41. In the year 1998, what is the difference between the Production index(2004-2006) of Finland and Production index(2004-2006) of Kazakhstan?
Your answer should be compact. 23.47. In the year 1998, what is the difference between the Production index(2004-2006) of Finland and Production index(2004-2006) of Senegal?
Your answer should be very brief. 13.91. In the year 1998, what is the difference between the Production index(2004-2006) in Kazakhstan and Production index(2004-2006) in Senegal?
Provide a succinct answer. -9.56. In the year 1999, what is the difference between the Production index(2004-2006) of Brunei Darussalam and Production index(2004-2006) of Finland?
Ensure brevity in your answer.  -17.99. In the year 1999, what is the difference between the Production index(2004-2006) of Brunei Darussalam and Production index(2004-2006) of Kazakhstan?
Your answer should be compact. -12.93. In the year 1999, what is the difference between the Production index(2004-2006) in Brunei Darussalam and Production index(2004-2006) in Senegal?
Provide a short and direct response. -30.47. In the year 1999, what is the difference between the Production index(2004-2006) of Finland and Production index(2004-2006) of Kazakhstan?
Ensure brevity in your answer.  5.06. In the year 1999, what is the difference between the Production index(2004-2006) in Finland and Production index(2004-2006) in Senegal?
Ensure brevity in your answer.  -12.48. In the year 1999, what is the difference between the Production index(2004-2006) in Kazakhstan and Production index(2004-2006) in Senegal?
Offer a very short reply. -17.54. In the year 2000, what is the difference between the Production index(2004-2006) of Brunei Darussalam and Production index(2004-2006) of Finland?
Keep it short and to the point. -13.6. In the year 2000, what is the difference between the Production index(2004-2006) of Brunei Darussalam and Production index(2004-2006) of Kazakhstan?
Your answer should be compact. 5.85. In the year 2000, what is the difference between the Production index(2004-2006) in Brunei Darussalam and Production index(2004-2006) in Senegal?
Provide a succinct answer. -21.51. In the year 2000, what is the difference between the Production index(2004-2006) in Finland and Production index(2004-2006) in Kazakhstan?
Make the answer very short. 19.45. In the year 2000, what is the difference between the Production index(2004-2006) in Finland and Production index(2004-2006) in Senegal?
Your answer should be very brief. -7.91. In the year 2000, what is the difference between the Production index(2004-2006) in Kazakhstan and Production index(2004-2006) in Senegal?
Your response must be concise. -27.36. In the year 2001, what is the difference between the Production index(2004-2006) of Brunei Darussalam and Production index(2004-2006) of Finland?
Ensure brevity in your answer.  0.3. In the year 2001, what is the difference between the Production index(2004-2006) of Brunei Darussalam and Production index(2004-2006) of Kazakhstan?
Provide a short and direct response. 4.82. In the year 2001, what is the difference between the Production index(2004-2006) of Brunei Darussalam and Production index(2004-2006) of Senegal?
Make the answer very short. -3.14. In the year 2001, what is the difference between the Production index(2004-2006) of Finland and Production index(2004-2006) of Kazakhstan?
Provide a short and direct response. 4.52. In the year 2001, what is the difference between the Production index(2004-2006) of Finland and Production index(2004-2006) of Senegal?
Offer a terse response. -3.44. In the year 2001, what is the difference between the Production index(2004-2006) of Kazakhstan and Production index(2004-2006) of Senegal?
Give a very brief answer. -7.96. In the year 2002, what is the difference between the Production index(2004-2006) in Brunei Darussalam and Production index(2004-2006) in Kazakhstan?
Offer a very short reply. 11.95. In the year 2002, what is the difference between the Production index(2004-2006) in Brunei Darussalam and Production index(2004-2006) in Senegal?
Make the answer very short. 39.13. In the year 2002, what is the difference between the Production index(2004-2006) of Finland and Production index(2004-2006) of Kazakhstan?
Your answer should be compact. 5.95. In the year 2002, what is the difference between the Production index(2004-2006) in Finland and Production index(2004-2006) in Senegal?
Offer a very short reply. 33.13. In the year 2002, what is the difference between the Production index(2004-2006) in Kazakhstan and Production index(2004-2006) in Senegal?
Offer a terse response. 27.18. In the year 2003, what is the difference between the Production index(2004-2006) in Brunei Darussalam and Production index(2004-2006) in Finland?
Make the answer very short. 6.93. In the year 2003, what is the difference between the Production index(2004-2006) in Brunei Darussalam and Production index(2004-2006) in Senegal?
Give a very brief answer. 11.32. In the year 2003, what is the difference between the Production index(2004-2006) of Finland and Production index(2004-2006) of Kazakhstan?
Make the answer very short. 3.97. In the year 2003, what is the difference between the Production index(2004-2006) in Finland and Production index(2004-2006) in Senegal?
Offer a terse response. 4.39. In the year 2003, what is the difference between the Production index(2004-2006) in Kazakhstan and Production index(2004-2006) in Senegal?
Provide a succinct answer. 0.42. In the year 2004, what is the difference between the Production index(2004-2006) in Brunei Darussalam and Production index(2004-2006) in Finland?
Offer a terse response. 3.93. In the year 2004, what is the difference between the Production index(2004-2006) of Brunei Darussalam and Production index(2004-2006) of Kazakhstan?
Make the answer very short. 8.89. In the year 2004, what is the difference between the Production index(2004-2006) of Finland and Production index(2004-2006) of Kazakhstan?
Keep it short and to the point. 4.96. In the year 2004, what is the difference between the Production index(2004-2006) of Finland and Production index(2004-2006) of Senegal?
Offer a terse response. 3.37. In the year 2004, what is the difference between the Production index(2004-2006) of Kazakhstan and Production index(2004-2006) of Senegal?
Ensure brevity in your answer.  -1.59. What is the ratio of the Production index(2004-2006) of Brunei Darussalam in 1997 to that in 1998?
Ensure brevity in your answer.  0.87. What is the ratio of the Production index(2004-2006) of Finland in 1997 to that in 1998?
Offer a very short reply. 1.12. What is the ratio of the Production index(2004-2006) of Kazakhstan in 1997 to that in 1998?
Provide a short and direct response. 1.22. What is the ratio of the Production index(2004-2006) of Senegal in 1997 to that in 1998?
Your response must be concise. 1.02. What is the ratio of the Production index(2004-2006) of Brunei Darussalam in 1997 to that in 1999?
Provide a succinct answer. 0.69. What is the ratio of the Production index(2004-2006) in Finland in 1997 to that in 1999?
Your answer should be very brief. 1.08. What is the ratio of the Production index(2004-2006) in Kazakhstan in 1997 to that in 1999?
Offer a very short reply. 0.92. What is the ratio of the Production index(2004-2006) of Senegal in 1997 to that in 1999?
Your answer should be compact. 0.73. What is the ratio of the Production index(2004-2006) in Brunei Darussalam in 1997 to that in 2000?
Make the answer very short. 0.6. What is the ratio of the Production index(2004-2006) of Finland in 1997 to that in 2000?
Your response must be concise. 1.01. What is the ratio of the Production index(2004-2006) in Senegal in 1997 to that in 2000?
Offer a very short reply. 0.72. What is the ratio of the Production index(2004-2006) in Brunei Darussalam in 1997 to that in 2001?
Provide a short and direct response. 0.52. What is the ratio of the Production index(2004-2006) in Finland in 1997 to that in 2001?
Keep it short and to the point. 1.02. What is the ratio of the Production index(2004-2006) of Kazakhstan in 1997 to that in 2001?
Your response must be concise. 0.86. What is the ratio of the Production index(2004-2006) in Senegal in 1997 to that in 2001?
Provide a succinct answer. 0.75. What is the ratio of the Production index(2004-2006) of Brunei Darussalam in 1997 to that in 2002?
Keep it short and to the point. 0.48. What is the ratio of the Production index(2004-2006) in Finland in 1997 to that in 2002?
Offer a very short reply. 0.99. What is the ratio of the Production index(2004-2006) of Kazakhstan in 1997 to that in 2002?
Offer a terse response. 0.84. What is the ratio of the Production index(2004-2006) of Senegal in 1997 to that in 2002?
Your answer should be very brief. 1.13. What is the ratio of the Production index(2004-2006) of Brunei Darussalam in 1997 to that in 2003?
Your response must be concise. 0.48. What is the ratio of the Production index(2004-2006) of Finland in 1997 to that in 2003?
Offer a very short reply. 1.02. What is the ratio of the Production index(2004-2006) of Kazakhstan in 1997 to that in 2003?
Provide a short and direct response. 0.85. What is the ratio of the Production index(2004-2006) in Senegal in 1997 to that in 2003?
Provide a succinct answer. 0.82. What is the ratio of the Production index(2004-2006) in Brunei Darussalam in 1997 to that in 2004?
Give a very brief answer. 0.5. What is the ratio of the Production index(2004-2006) in Finland in 1997 to that in 2004?
Offer a terse response. 1.02. What is the ratio of the Production index(2004-2006) of Kazakhstan in 1997 to that in 2004?
Make the answer very short. 0.86. What is the ratio of the Production index(2004-2006) of Senegal in 1997 to that in 2004?
Provide a succinct answer. 0.81. What is the ratio of the Production index(2004-2006) of Brunei Darussalam in 1998 to that in 1999?
Ensure brevity in your answer.  0.79. What is the ratio of the Production index(2004-2006) of Finland in 1998 to that in 1999?
Give a very brief answer. 0.97. What is the ratio of the Production index(2004-2006) in Kazakhstan in 1998 to that in 1999?
Keep it short and to the point. 0.75. What is the ratio of the Production index(2004-2006) of Senegal in 1998 to that in 1999?
Give a very brief answer. 0.72. What is the ratio of the Production index(2004-2006) in Brunei Darussalam in 1998 to that in 2000?
Provide a succinct answer. 0.69. What is the ratio of the Production index(2004-2006) in Finland in 1998 to that in 2000?
Ensure brevity in your answer.  0.9. What is the ratio of the Production index(2004-2006) of Kazakhstan in 1998 to that in 2000?
Make the answer very short. 0.83. What is the ratio of the Production index(2004-2006) of Senegal in 1998 to that in 2000?
Provide a succinct answer. 0.7. What is the ratio of the Production index(2004-2006) of Brunei Darussalam in 1998 to that in 2001?
Keep it short and to the point. 0.6. What is the ratio of the Production index(2004-2006) of Finland in 1998 to that in 2001?
Give a very brief answer. 0.91. What is the ratio of the Production index(2004-2006) of Kazakhstan in 1998 to that in 2001?
Provide a succinct answer. 0.7. What is the ratio of the Production index(2004-2006) of Senegal in 1998 to that in 2001?
Provide a succinct answer. 0.74. What is the ratio of the Production index(2004-2006) of Brunei Darussalam in 1998 to that in 2002?
Your response must be concise. 0.55. What is the ratio of the Production index(2004-2006) in Finland in 1998 to that in 2002?
Keep it short and to the point. 0.88. What is the ratio of the Production index(2004-2006) in Kazakhstan in 1998 to that in 2002?
Make the answer very short. 0.69. What is the ratio of the Production index(2004-2006) of Senegal in 1998 to that in 2002?
Give a very brief answer. 1.11. What is the ratio of the Production index(2004-2006) in Brunei Darussalam in 1998 to that in 2003?
Provide a succinct answer. 0.56. What is the ratio of the Production index(2004-2006) in Finland in 1998 to that in 2003?
Offer a very short reply. 0.91. What is the ratio of the Production index(2004-2006) of Kazakhstan in 1998 to that in 2003?
Your answer should be very brief. 0.7. What is the ratio of the Production index(2004-2006) of Senegal in 1998 to that in 2003?
Offer a terse response. 0.8. What is the ratio of the Production index(2004-2006) in Brunei Darussalam in 1998 to that in 2004?
Ensure brevity in your answer.  0.58. What is the ratio of the Production index(2004-2006) of Finland in 1998 to that in 2004?
Ensure brevity in your answer.  0.91. What is the ratio of the Production index(2004-2006) of Kazakhstan in 1998 to that in 2004?
Give a very brief answer. 0.71. What is the ratio of the Production index(2004-2006) in Senegal in 1998 to that in 2004?
Your answer should be compact. 0.8. What is the ratio of the Production index(2004-2006) of Brunei Darussalam in 1999 to that in 2000?
Give a very brief answer. 0.87. What is the ratio of the Production index(2004-2006) of Finland in 1999 to that in 2000?
Provide a short and direct response. 0.93. What is the ratio of the Production index(2004-2006) in Kazakhstan in 1999 to that in 2000?
Keep it short and to the point. 1.1. What is the ratio of the Production index(2004-2006) in Senegal in 1999 to that in 2000?
Make the answer very short. 0.98. What is the ratio of the Production index(2004-2006) of Brunei Darussalam in 1999 to that in 2001?
Your answer should be very brief. 0.76. What is the ratio of the Production index(2004-2006) in Finland in 1999 to that in 2001?
Offer a terse response. 0.94. What is the ratio of the Production index(2004-2006) of Kazakhstan in 1999 to that in 2001?
Your answer should be very brief. 0.93. What is the ratio of the Production index(2004-2006) in Senegal in 1999 to that in 2001?
Offer a very short reply. 1.03. What is the ratio of the Production index(2004-2006) in Brunei Darussalam in 1999 to that in 2002?
Ensure brevity in your answer.  0.69. What is the ratio of the Production index(2004-2006) of Finland in 1999 to that in 2002?
Keep it short and to the point. 0.91. What is the ratio of the Production index(2004-2006) in Senegal in 1999 to that in 2002?
Make the answer very short. 1.54. What is the ratio of the Production index(2004-2006) in Brunei Darussalam in 1999 to that in 2003?
Give a very brief answer. 0.71. What is the ratio of the Production index(2004-2006) of Finland in 1999 to that in 2003?
Your response must be concise. 0.94. What is the ratio of the Production index(2004-2006) of Kazakhstan in 1999 to that in 2003?
Your response must be concise. 0.93. What is the ratio of the Production index(2004-2006) of Senegal in 1999 to that in 2003?
Your answer should be very brief. 1.12. What is the ratio of the Production index(2004-2006) of Brunei Darussalam in 1999 to that in 2004?
Ensure brevity in your answer.  0.73. What is the ratio of the Production index(2004-2006) in Finland in 1999 to that in 2004?
Offer a very short reply. 0.94. What is the ratio of the Production index(2004-2006) in Kazakhstan in 1999 to that in 2004?
Provide a short and direct response. 0.94. What is the ratio of the Production index(2004-2006) in Senegal in 1999 to that in 2004?
Offer a terse response. 1.11. What is the ratio of the Production index(2004-2006) in Brunei Darussalam in 2000 to that in 2001?
Offer a terse response. 0.87. What is the ratio of the Production index(2004-2006) of Finland in 2000 to that in 2001?
Ensure brevity in your answer.  1.01. What is the ratio of the Production index(2004-2006) of Kazakhstan in 2000 to that in 2001?
Provide a succinct answer. 0.85. What is the ratio of the Production index(2004-2006) in Senegal in 2000 to that in 2001?
Ensure brevity in your answer.  1.05. What is the ratio of the Production index(2004-2006) in Brunei Darussalam in 2000 to that in 2002?
Ensure brevity in your answer.  0.8. What is the ratio of the Production index(2004-2006) in Finland in 2000 to that in 2002?
Offer a terse response. 0.98. What is the ratio of the Production index(2004-2006) of Kazakhstan in 2000 to that in 2002?
Provide a short and direct response. 0.83. What is the ratio of the Production index(2004-2006) in Senegal in 2000 to that in 2002?
Provide a short and direct response. 1.57. What is the ratio of the Production index(2004-2006) in Brunei Darussalam in 2000 to that in 2003?
Provide a short and direct response. 0.81. What is the ratio of the Production index(2004-2006) in Finland in 2000 to that in 2003?
Provide a short and direct response. 1.01. What is the ratio of the Production index(2004-2006) of Kazakhstan in 2000 to that in 2003?
Your answer should be very brief. 0.84. What is the ratio of the Production index(2004-2006) in Senegal in 2000 to that in 2003?
Ensure brevity in your answer.  1.14. What is the ratio of the Production index(2004-2006) in Brunei Darussalam in 2000 to that in 2004?
Your answer should be compact. 0.84. What is the ratio of the Production index(2004-2006) in Finland in 2000 to that in 2004?
Provide a short and direct response. 1.01. What is the ratio of the Production index(2004-2006) of Kazakhstan in 2000 to that in 2004?
Your response must be concise. 0.86. What is the ratio of the Production index(2004-2006) in Senegal in 2000 to that in 2004?
Make the answer very short. 1.13. What is the ratio of the Production index(2004-2006) of Finland in 2001 to that in 2002?
Offer a very short reply. 0.97. What is the ratio of the Production index(2004-2006) in Kazakhstan in 2001 to that in 2002?
Your answer should be compact. 0.98. What is the ratio of the Production index(2004-2006) in Senegal in 2001 to that in 2002?
Provide a succinct answer. 1.49. What is the ratio of the Production index(2004-2006) in Brunei Darussalam in 2001 to that in 2003?
Make the answer very short. 0.94. What is the ratio of the Production index(2004-2006) of Kazakhstan in 2001 to that in 2003?
Your response must be concise. 0.99. What is the ratio of the Production index(2004-2006) in Senegal in 2001 to that in 2003?
Give a very brief answer. 1.08. What is the ratio of the Production index(2004-2006) of Brunei Darussalam in 2001 to that in 2004?
Make the answer very short. 0.97. What is the ratio of the Production index(2004-2006) in Senegal in 2001 to that in 2004?
Make the answer very short. 1.07. What is the ratio of the Production index(2004-2006) in Brunei Darussalam in 2002 to that in 2003?
Your response must be concise. 1.02. What is the ratio of the Production index(2004-2006) of Finland in 2002 to that in 2003?
Your answer should be compact. 1.03. What is the ratio of the Production index(2004-2006) of Kazakhstan in 2002 to that in 2003?
Your response must be concise. 1.01. What is the ratio of the Production index(2004-2006) of Senegal in 2002 to that in 2003?
Offer a terse response. 0.73. What is the ratio of the Production index(2004-2006) in Brunei Darussalam in 2002 to that in 2004?
Provide a succinct answer. 1.05. What is the ratio of the Production index(2004-2006) of Finland in 2002 to that in 2004?
Make the answer very short. 1.03. What is the ratio of the Production index(2004-2006) in Kazakhstan in 2002 to that in 2004?
Offer a very short reply. 1.02. What is the ratio of the Production index(2004-2006) in Senegal in 2002 to that in 2004?
Make the answer very short. 0.72. What is the ratio of the Production index(2004-2006) of Brunei Darussalam in 2003 to that in 2004?
Provide a succinct answer. 1.03. What is the ratio of the Production index(2004-2006) of Kazakhstan in 2003 to that in 2004?
Your answer should be compact. 1.01. What is the ratio of the Production index(2004-2006) in Senegal in 2003 to that in 2004?
Offer a very short reply. 0.99. What is the difference between the highest and the second highest Production index(2004-2006) in Brunei Darussalam?
Provide a succinct answer. 2.16. What is the difference between the highest and the second highest Production index(2004-2006) in Finland?
Provide a short and direct response. 1.22. What is the difference between the highest and the second highest Production index(2004-2006) of Kazakhstan?
Make the answer very short. 1.11. What is the difference between the highest and the second highest Production index(2004-2006) of Senegal?
Provide a succinct answer. 2.06. What is the difference between the highest and the lowest Production index(2004-2006) in Brunei Darussalam?
Provide a short and direct response. 56.1. What is the difference between the highest and the lowest Production index(2004-2006) of Finland?
Make the answer very short. 11.95. What is the difference between the highest and the lowest Production index(2004-2006) of Kazakhstan?
Ensure brevity in your answer.  29.47. What is the difference between the highest and the lowest Production index(2004-2006) in Senegal?
Provide a short and direct response. 38.87. 